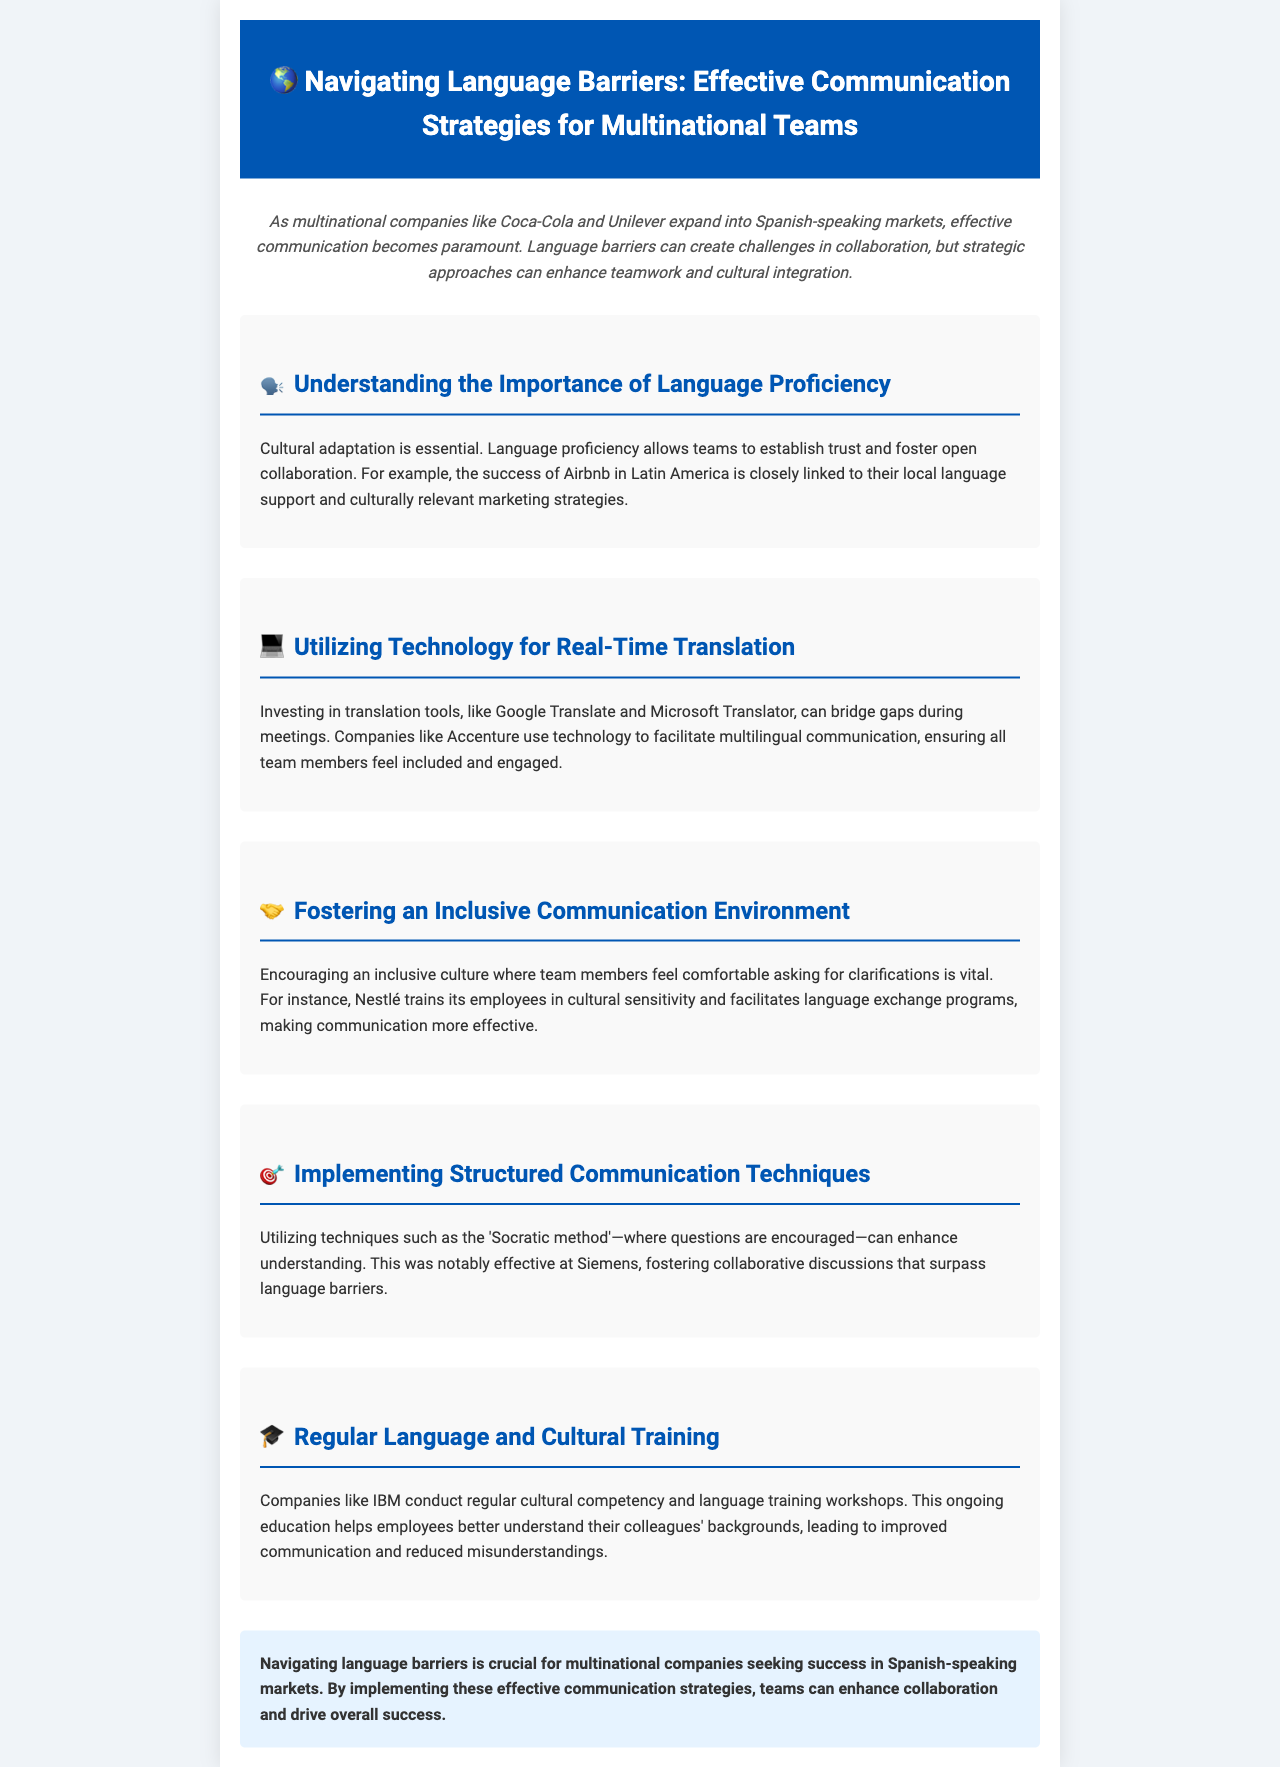what is the title of the newsletter? The title is explicitly mentioned at the beginning of the document, highlighting the focus on communication strategies for multinational teams.
Answer: Navigating Language Barriers: Effective Communication Strategies for Multinational Teams who are two companies mentioned in the document? The document references Coca-Cola and Unilever as examples of multinational companies expanding into Spanish-speaking markets.
Answer: Coca-Cola, Unilever what communication tool is suggested in the document for real-time translation? The document indicates that companies can use translation tools like Google Translate and Microsoft Translator to assist in communication.
Answer: Google Translate, Microsoft Translator which method is mentioned as effective for enhancing understanding? The document specifically mentions the 'Socratic method' as a structured communication technique that has proven effective in fostering discussions.
Answer: Socratic method what training does IBM conduct regularly according to the document? The document states that IBM conducts cultural competency and language training workshops regularly to improve employee interactions.
Answer: Cultural competency and language training how does Nestlé enhance communication among team members? The document describes how Nestlé trains employees in cultural sensitivity and facilitates language exchange programs to improve communication.
Answer: Cultural sensitivity training and language exchange programs what is a key benefit of language proficiency mentioned in the document? The document highlights that language proficiency allows teams to establish trust and foster open collaboration, which is essential for success.
Answer: Establish trust and foster collaboration which company is noted for effectively utilizing technology to facilitate multilingual communication? The document cites Accenture as an example of a company that uses technology to ensure inclusivity in communication across languages.
Answer: Accenture what is the overall conclusion regarding language barriers for multinational companies? The document concludes that navigating language barriers is crucial for success in Spanish-speaking markets and emphasizes the implementation of effective strategies.
Answer: Crucial for success in Spanish-speaking markets 